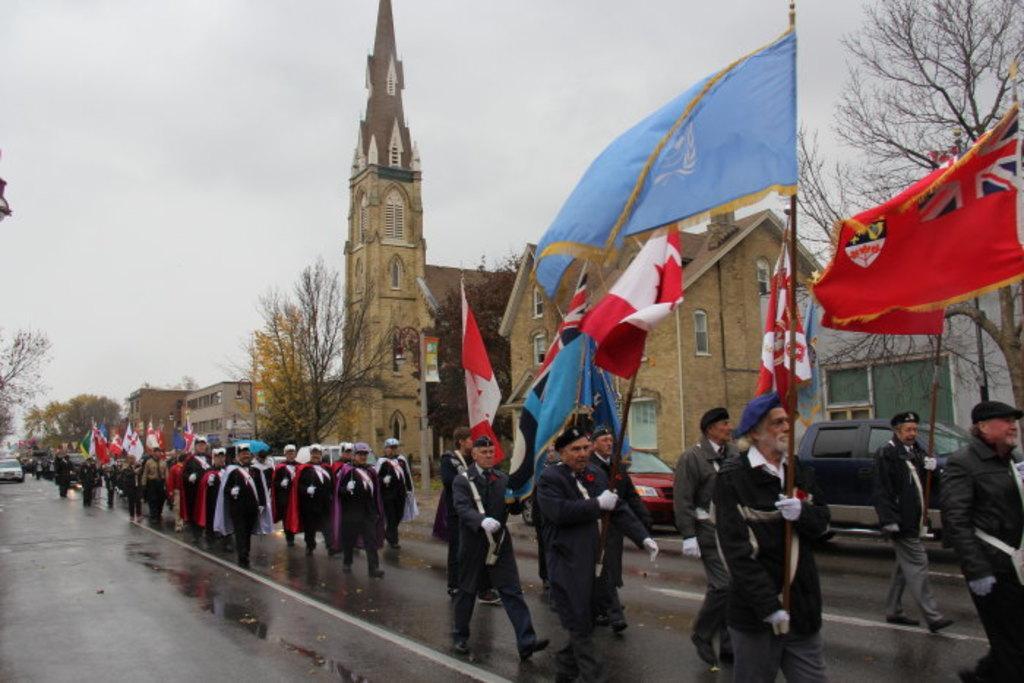How would you summarize this image in a sentence or two? In this image I can see a crowd on the road and flags. In the background I can see buildings, towers, trees, windows and the sky. This image is taken during a rainy day on the road. 